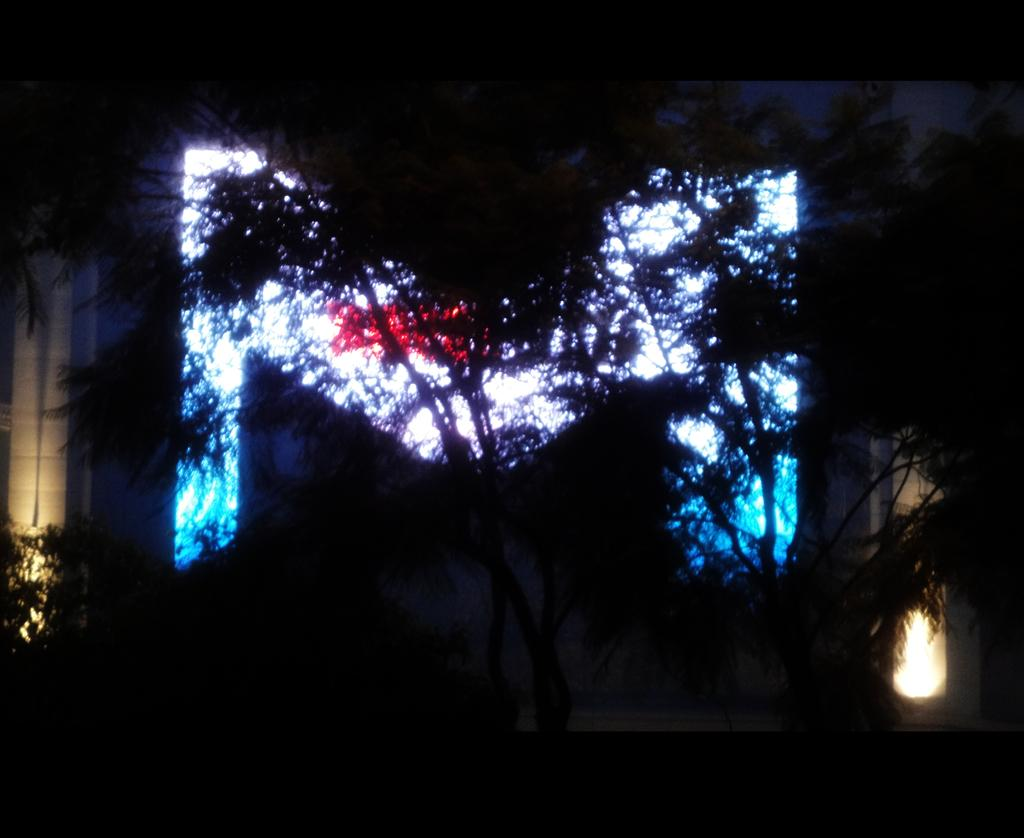What type of natural elements can be seen in the image? There are trees in the image. What artificial elements can be seen in the image? There are lights in the image. Can you describe any other objects in the image? Unfortunately, the specific nature of other objects in the image is not clear from the transcript. What is the size of the connection between the trees in the image? There is no connection between the trees mentioned in the image, so it is not possible to determine its size. 